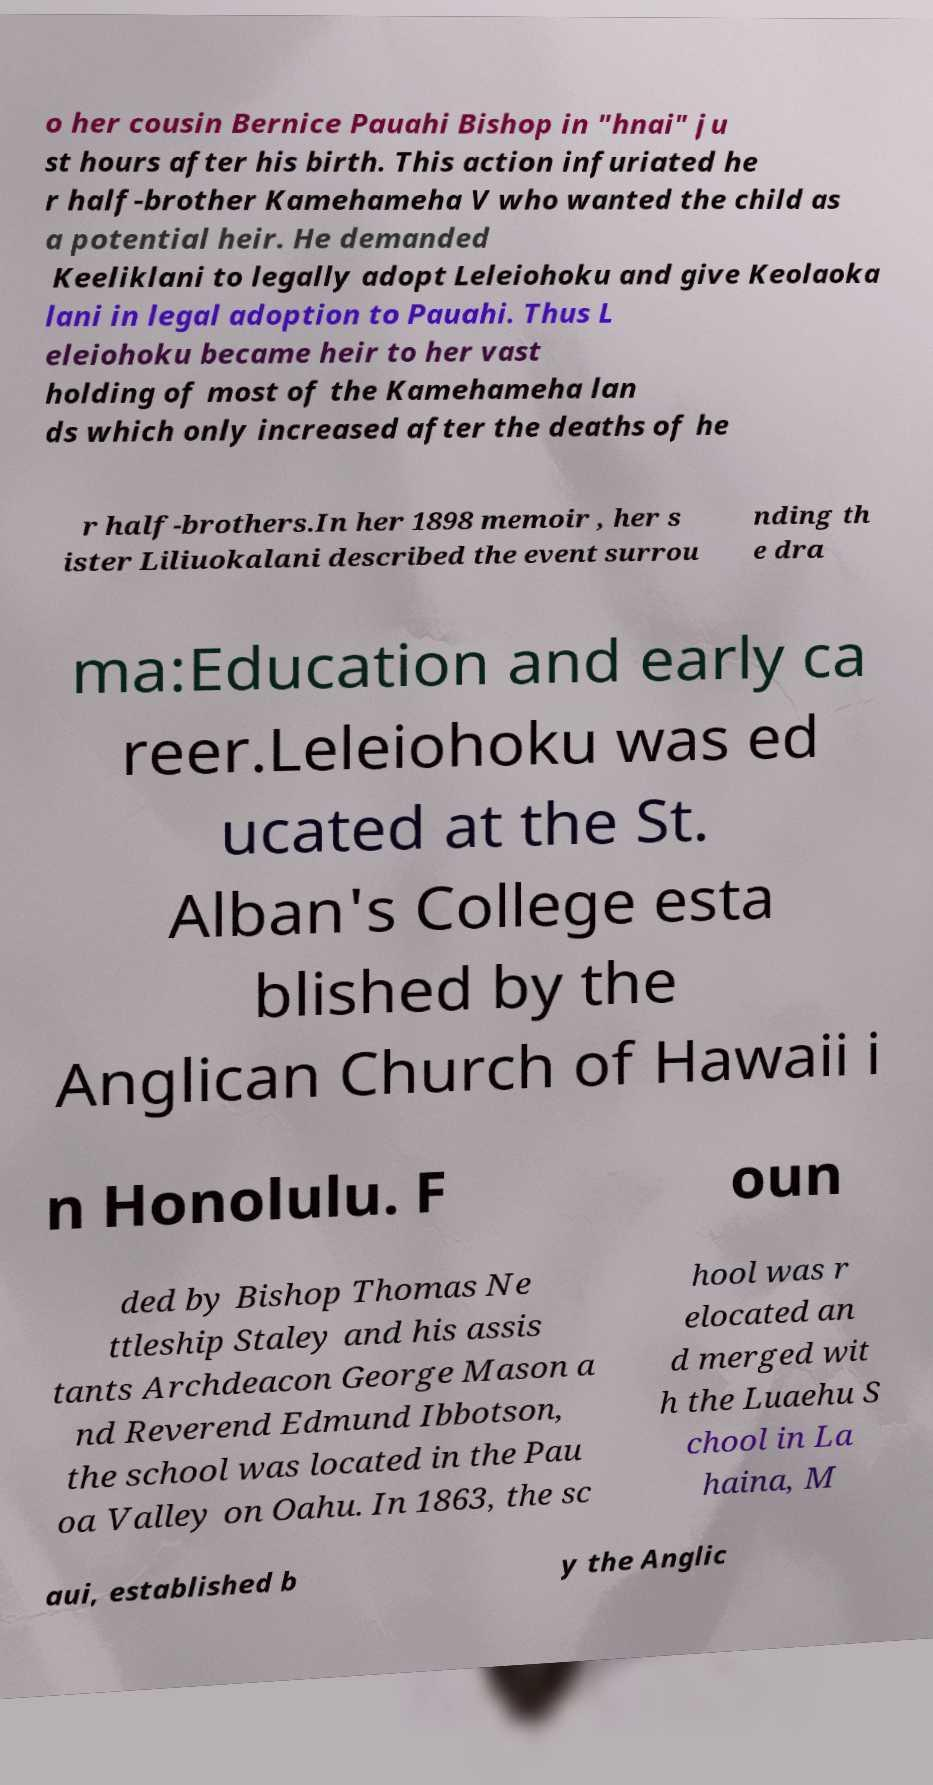For documentation purposes, I need the text within this image transcribed. Could you provide that? o her cousin Bernice Pauahi Bishop in "hnai" ju st hours after his birth. This action infuriated he r half-brother Kamehameha V who wanted the child as a potential heir. He demanded Keeliklani to legally adopt Leleiohoku and give Keolaoka lani in legal adoption to Pauahi. Thus L eleiohoku became heir to her vast holding of most of the Kamehameha lan ds which only increased after the deaths of he r half-brothers.In her 1898 memoir , her s ister Liliuokalani described the event surrou nding th e dra ma:Education and early ca reer.Leleiohoku was ed ucated at the St. Alban's College esta blished by the Anglican Church of Hawaii i n Honolulu. F oun ded by Bishop Thomas Ne ttleship Staley and his assis tants Archdeacon George Mason a nd Reverend Edmund Ibbotson, the school was located in the Pau oa Valley on Oahu. In 1863, the sc hool was r elocated an d merged wit h the Luaehu S chool in La haina, M aui, established b y the Anglic 